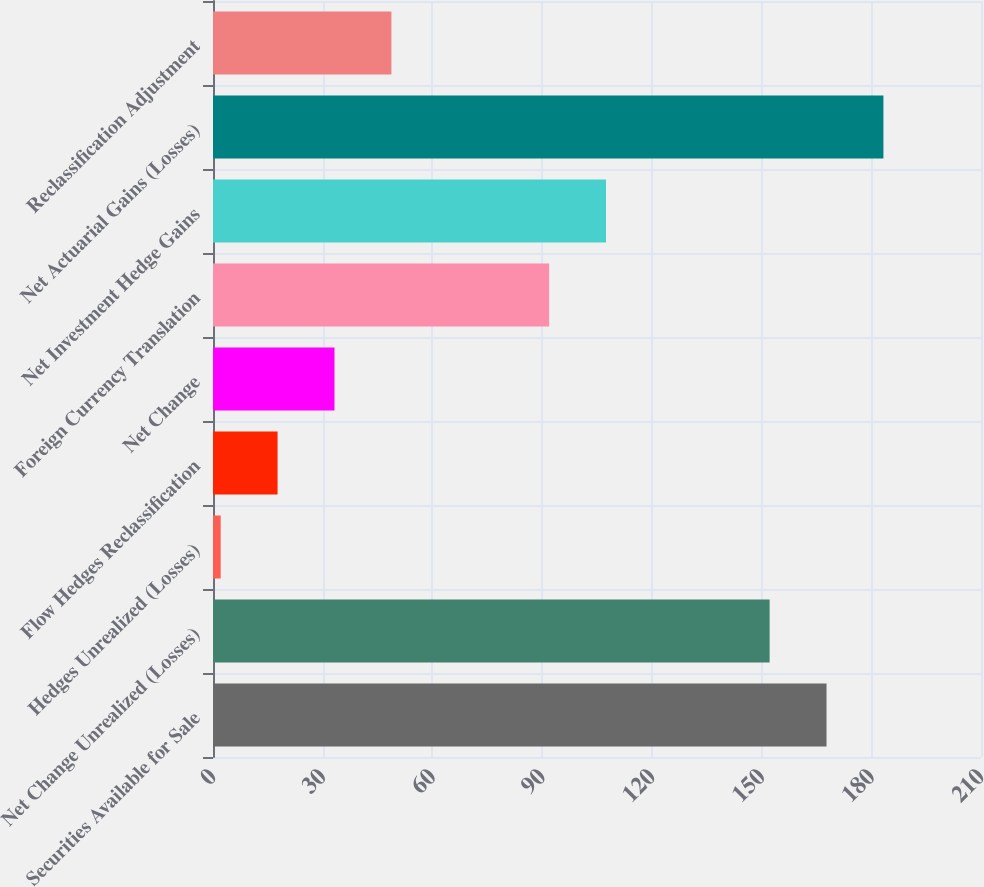<chart> <loc_0><loc_0><loc_500><loc_500><bar_chart><fcel>Securities Available for Sale<fcel>Net Change Unrealized (Losses)<fcel>Hedges Unrealized (Losses)<fcel>Flow Hedges Reclassification<fcel>Net Change<fcel>Foreign Currency Translation<fcel>Net Investment Hedge Gains<fcel>Net Actuarial Gains (Losses)<fcel>Reclassification Adjustment<nl><fcel>167.76<fcel>152.2<fcel>2.1<fcel>17.66<fcel>33.22<fcel>91.9<fcel>107.46<fcel>183.32<fcel>48.78<nl></chart> 